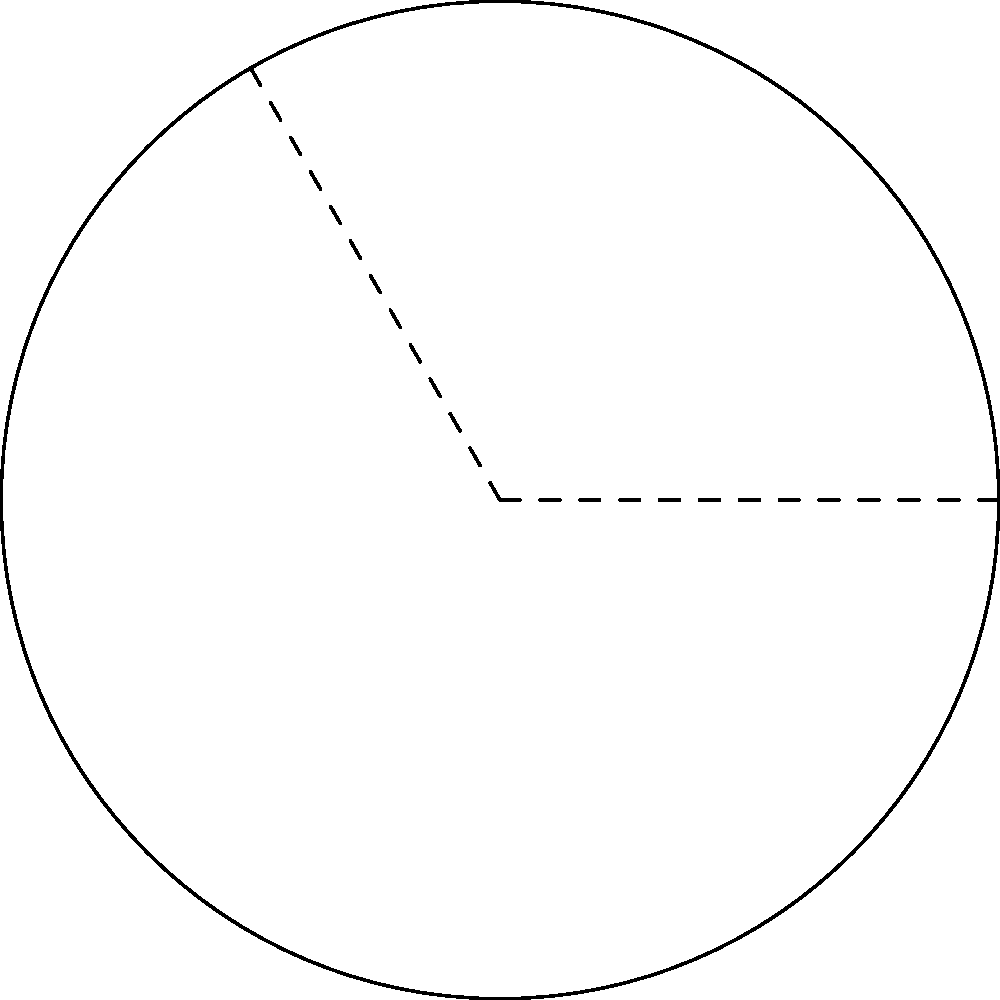A curved driveway needs resurfacing. The driveway forms an arc of a circle with radius 15 meters, and the central angle of the arc is 120°. What is the length of the driveway that needs to be resurfaced? To find the length of the curved driveway (arc length), we'll use the formula:

$$ s = r\theta $$

Where:
$s$ = arc length
$r$ = radius of the circle
$\theta$ = central angle in radians

Steps:
1) We're given the radius $r = 15$ meters.

2) The central angle is 120°, but we need to convert it to radians:
   $\theta = 120° \times \frac{\pi}{180°} = \frac{2\pi}{3}$ radians

3) Now we can plug these values into our formula:
   $$ s = r\theta = 15 \times \frac{2\pi}{3} = 10\pi \approx 31.42 \text{ meters} $$

Therefore, the length of the driveway that needs to be resurfaced is $10\pi$ meters or approximately 31.42 meters.
Answer: $10\pi$ meters 